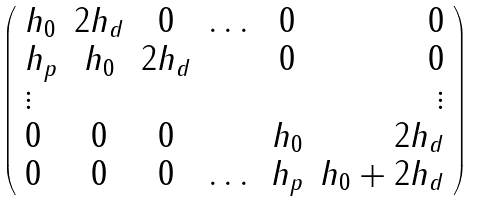Convert formula to latex. <formula><loc_0><loc_0><loc_500><loc_500>\left ( \begin{array} { l c c c c r } h _ { 0 } & 2 h _ { d } & 0 & \dots & 0 & 0 \\ h _ { p } & h _ { 0 } & 2 h _ { d } & & 0 & 0 \\ \vdots & & & & & \vdots \\ 0 & 0 & 0 & & h _ { 0 } & 2 h _ { d } \\ 0 & 0 & 0 & \dots & h _ { p } & h _ { 0 } + 2 h _ { d } \\ \end{array} \right )</formula> 